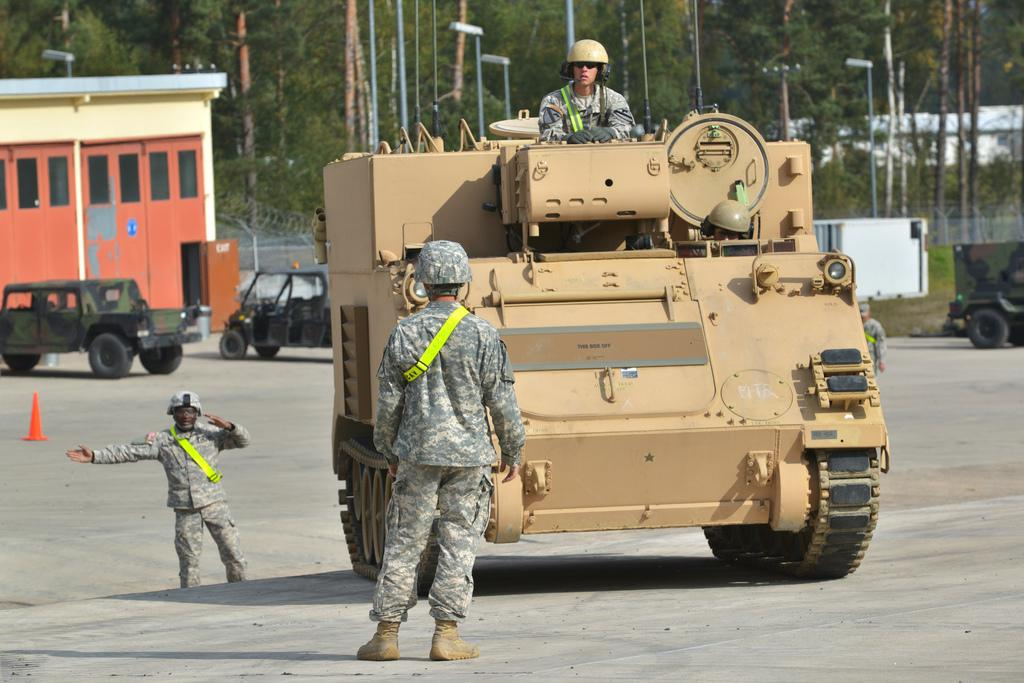What is the person in the image doing? There is a person riding a vehicle in the image. What are the other people in the image doing? Two persons are standing on the road in the image. What can be seen in the distance in the image? There are houses, trees, and vehicles visible in the background of the image. What sound can be heard coming from the trees in the image? There is no sound present in the image, as it is a still photograph. In which direction are the people walking in the image? The image does not show the people walking; they are standing on the road. 